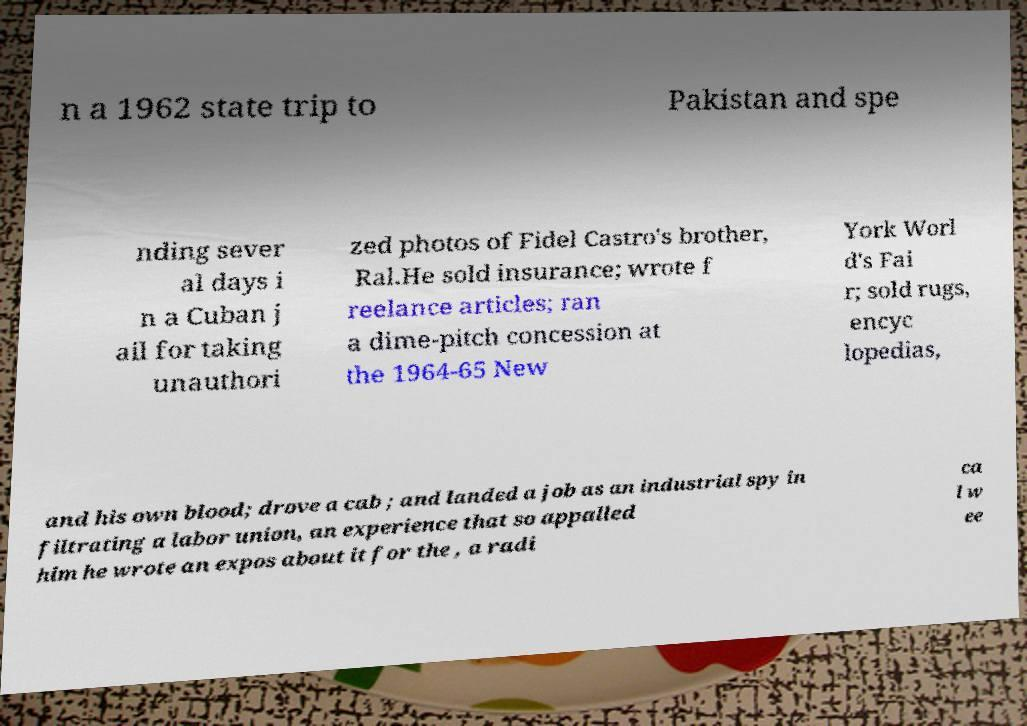Could you assist in decoding the text presented in this image and type it out clearly? n a 1962 state trip to Pakistan and spe nding sever al days i n a Cuban j ail for taking unauthori zed photos of Fidel Castro's brother, Ral.He sold insurance; wrote f reelance articles; ran a dime-pitch concession at the 1964-65 New York Worl d's Fai r; sold rugs, encyc lopedias, and his own blood; drove a cab ; and landed a job as an industrial spy in filtrating a labor union, an experience that so appalled him he wrote an expos about it for the , a radi ca l w ee 